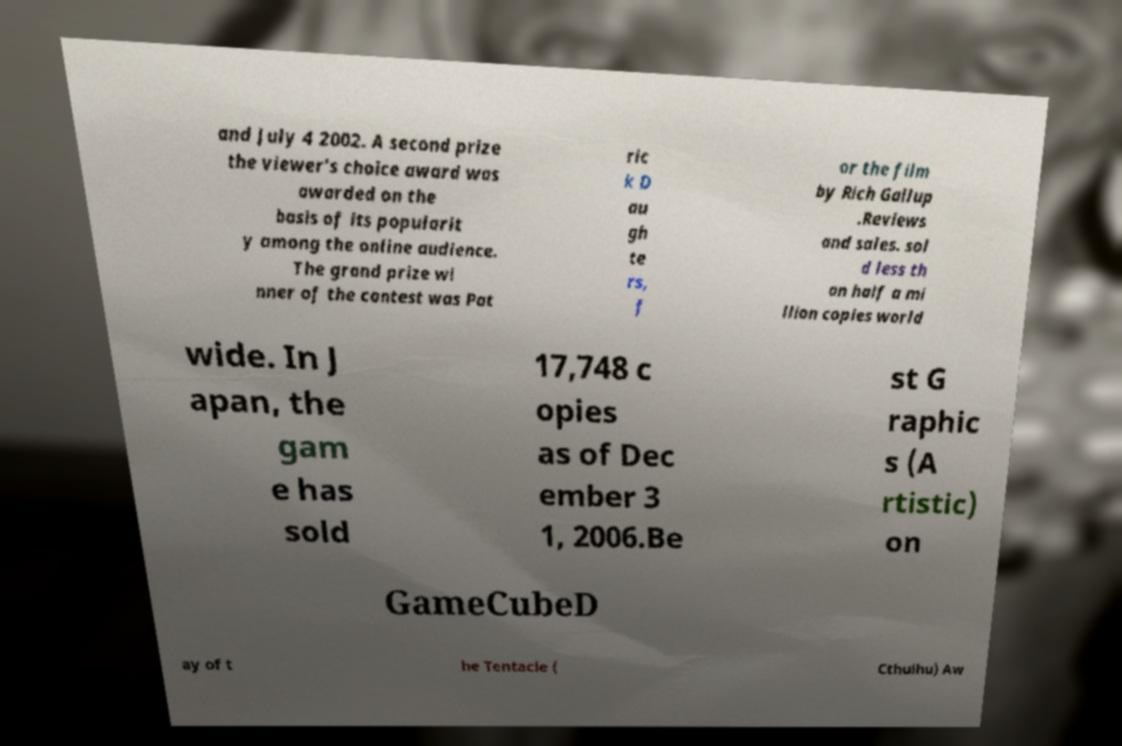I need the written content from this picture converted into text. Can you do that? and July 4 2002. A second prize the viewer's choice award was awarded on the basis of its popularit y among the online audience. The grand prize wi nner of the contest was Pat ric k D au gh te rs, f or the film by Rich Gallup .Reviews and sales. sol d less th an half a mi llion copies world wide. In J apan, the gam e has sold 17,748 c opies as of Dec ember 3 1, 2006.Be st G raphic s (A rtistic) on GameCubeD ay of t he Tentacle ( Cthulhu) Aw 